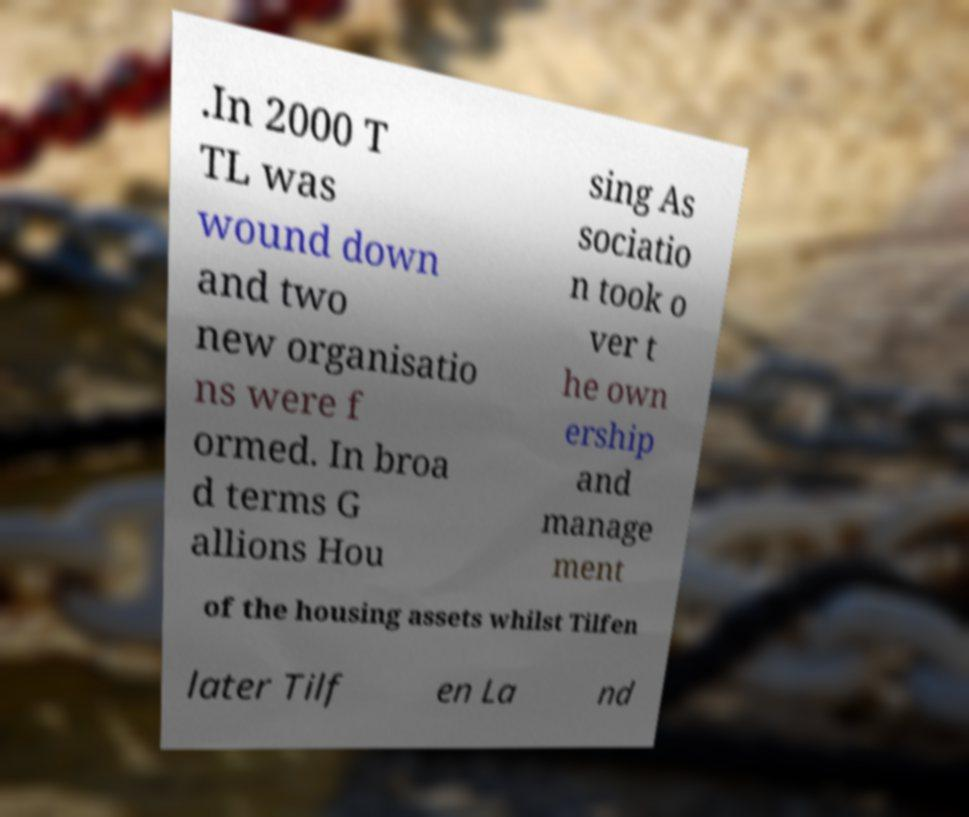What messages or text are displayed in this image? I need them in a readable, typed format. .In 2000 T TL was wound down and two new organisatio ns were f ormed. In broa d terms G allions Hou sing As sociatio n took o ver t he own ership and manage ment of the housing assets whilst Tilfen later Tilf en La nd 